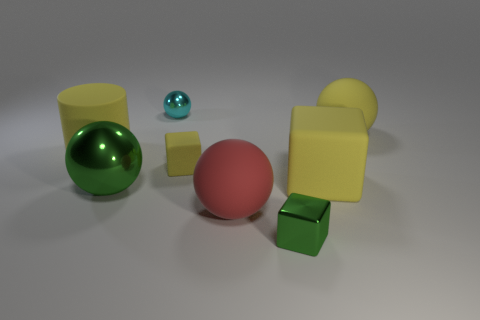Subtract 2 spheres. How many spheres are left? 2 Subtract all blue spheres. Subtract all green cylinders. How many spheres are left? 4 Add 2 large brown matte balls. How many objects exist? 10 Subtract all cylinders. How many objects are left? 7 Subtract 0 blue cylinders. How many objects are left? 8 Subtract all large green cubes. Subtract all big red things. How many objects are left? 7 Add 8 large metallic objects. How many large metallic objects are left? 9 Add 1 large green spheres. How many large green spheres exist? 2 